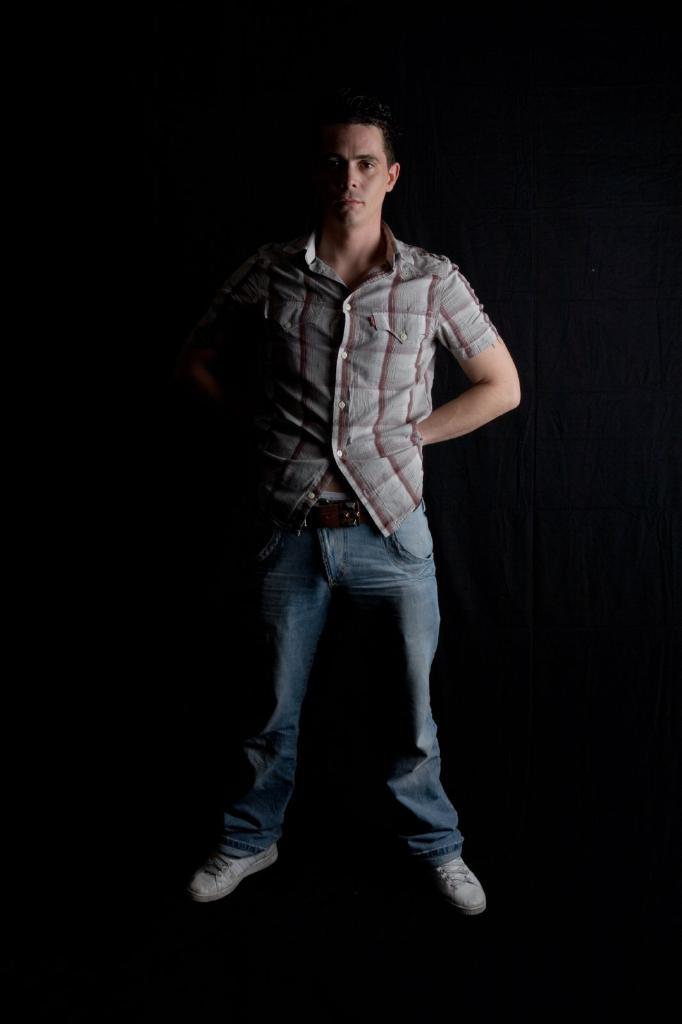Who is the main subject in the image? There is a person at the center of the image. What is the person wearing on their upper body? The person is wearing a shirt. What color are the jeans the person is wearing? The person is wearing blue color jeans. What type of shoes is the person wearing? The person is wearing white color shoes. What is the color of the background in the image? The background of the image is black. Is the person in the image offering a kite to someone? There is no kite present in the image, and the person's actions are not described, so it cannot be determined if they are offering a kite to someone. 